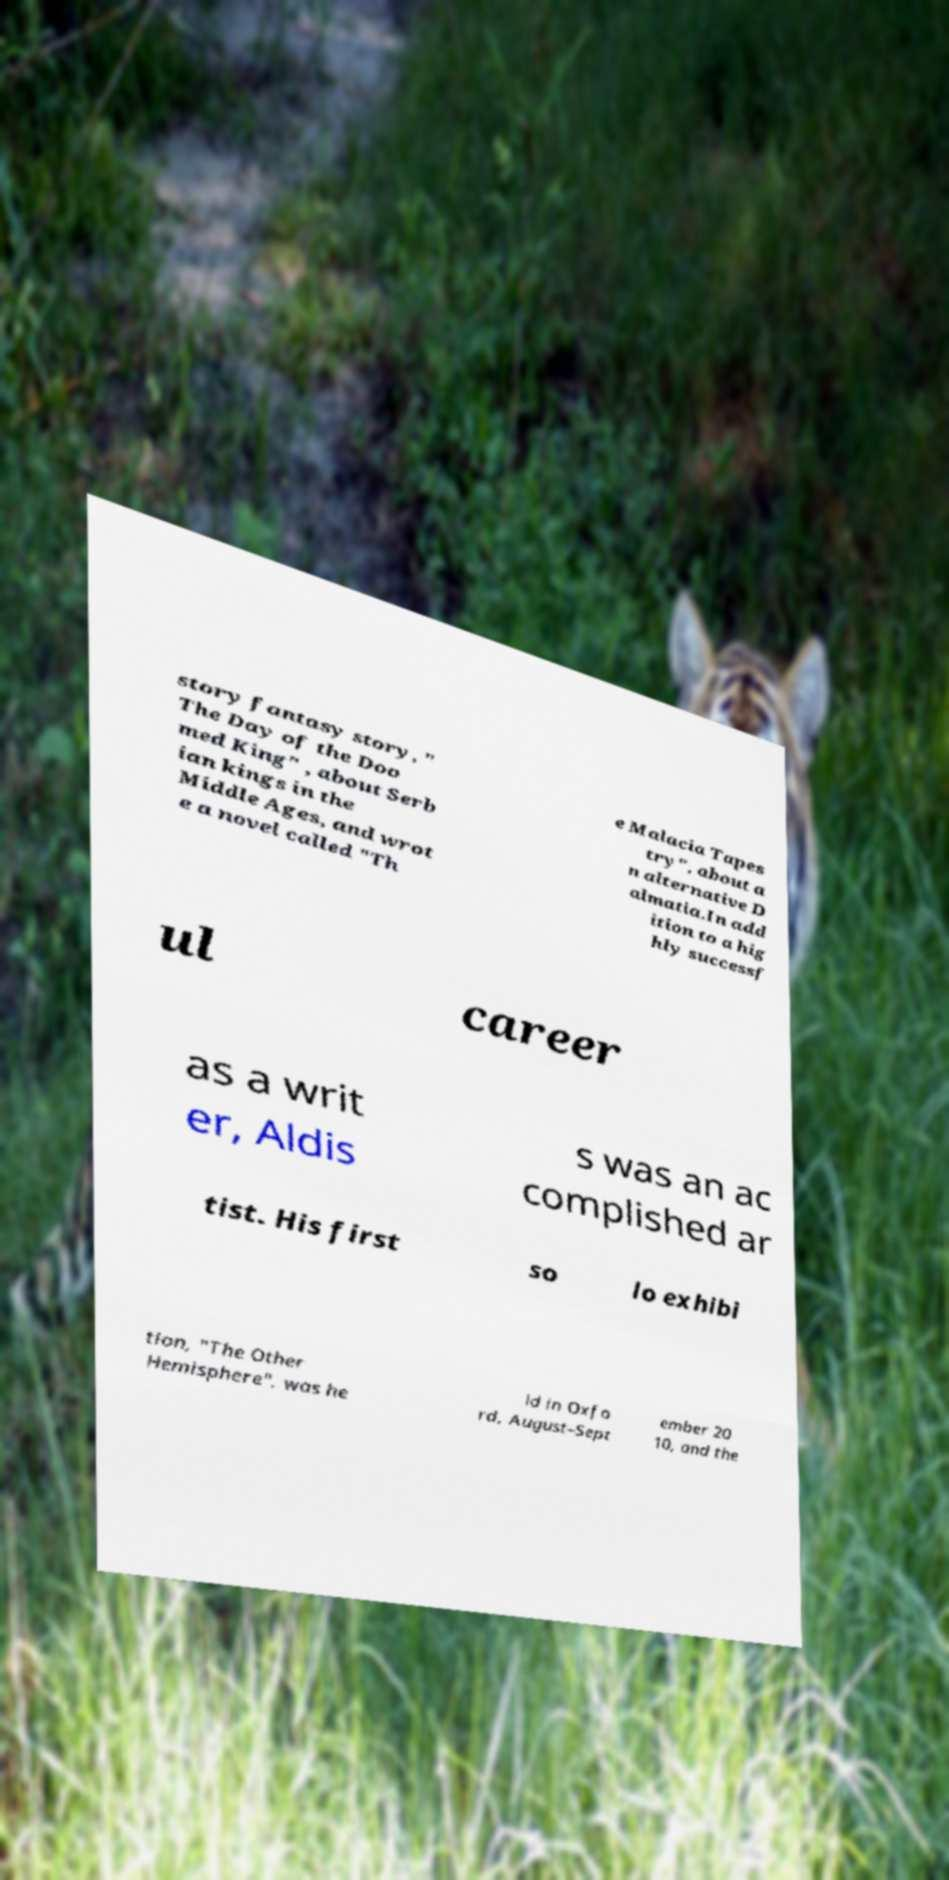What messages or text are displayed in this image? I need them in a readable, typed format. story fantasy story, " The Day of the Doo med King" , about Serb ian kings in the Middle Ages, and wrot e a novel called "Th e Malacia Tapes try", about a n alternative D almatia.In add ition to a hig hly successf ul career as a writ er, Aldis s was an ac complished ar tist. His first so lo exhibi tion, "The Other Hemisphere", was he ld in Oxfo rd, August–Sept ember 20 10, and the 